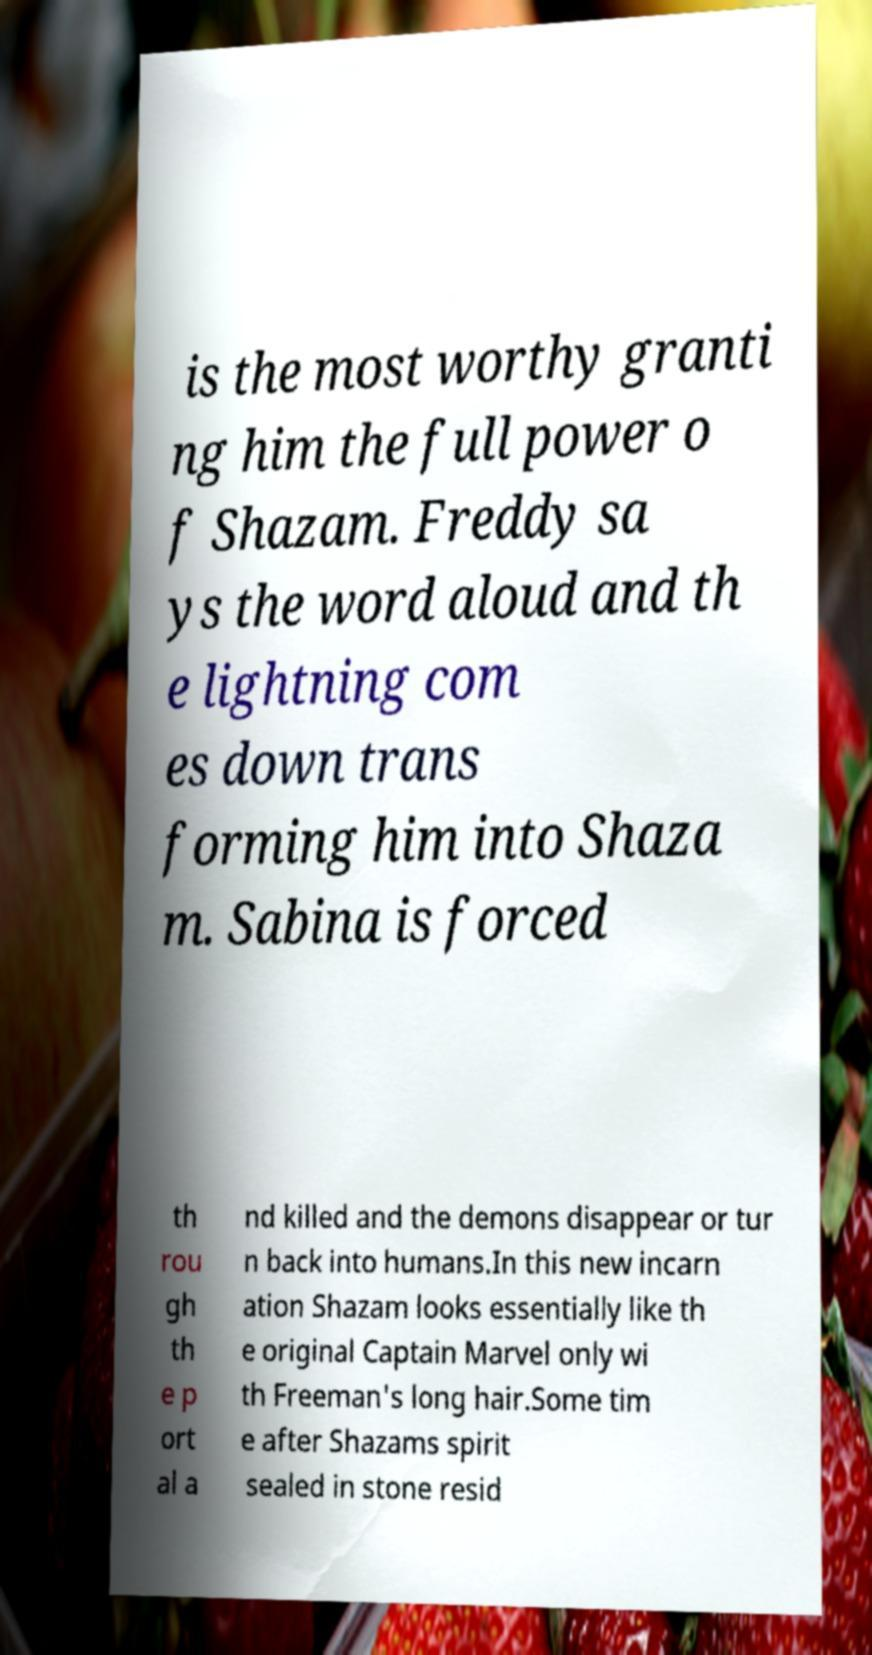Please identify and transcribe the text found in this image. is the most worthy granti ng him the full power o f Shazam. Freddy sa ys the word aloud and th e lightning com es down trans forming him into Shaza m. Sabina is forced th rou gh th e p ort al a nd killed and the demons disappear or tur n back into humans.In this new incarn ation Shazam looks essentially like th e original Captain Marvel only wi th Freeman's long hair.Some tim e after Shazams spirit sealed in stone resid 